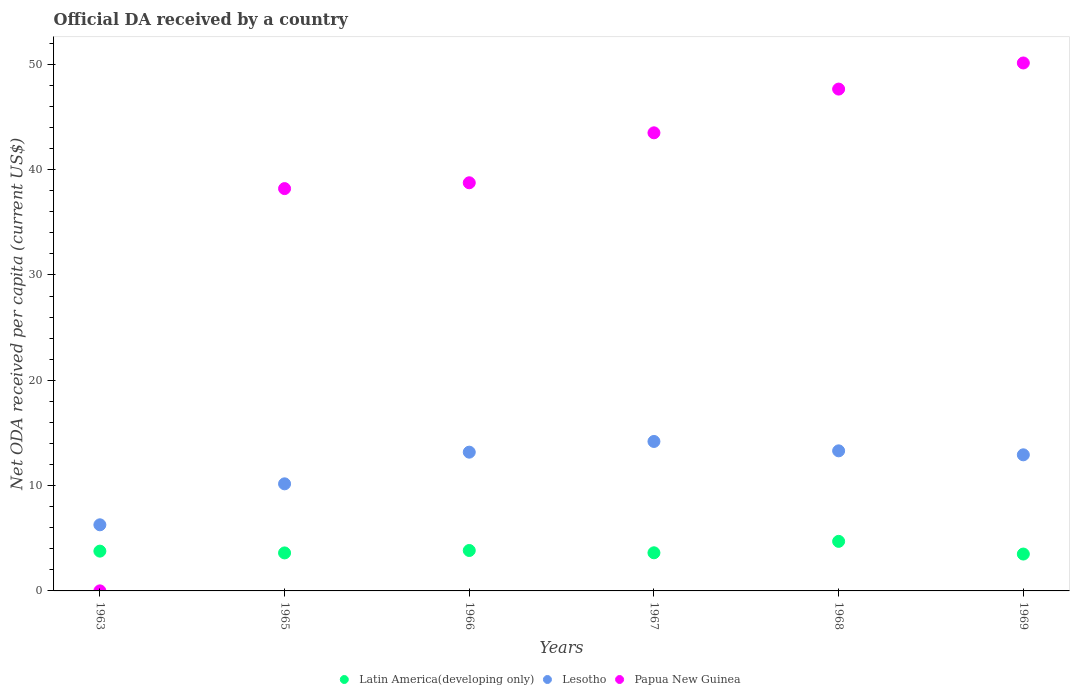How many different coloured dotlines are there?
Provide a succinct answer. 3. Is the number of dotlines equal to the number of legend labels?
Your answer should be compact. Yes. What is the ODA received in in Papua New Guinea in 1965?
Your response must be concise. 38.2. Across all years, what is the maximum ODA received in in Latin America(developing only)?
Your response must be concise. 4.71. Across all years, what is the minimum ODA received in in Latin America(developing only)?
Make the answer very short. 3.5. In which year was the ODA received in in Papua New Guinea maximum?
Your answer should be very brief. 1969. In which year was the ODA received in in Latin America(developing only) minimum?
Provide a succinct answer. 1969. What is the total ODA received in in Lesotho in the graph?
Make the answer very short. 70.04. What is the difference between the ODA received in in Papua New Guinea in 1966 and that in 1968?
Provide a succinct answer. -8.9. What is the difference between the ODA received in in Lesotho in 1969 and the ODA received in in Latin America(developing only) in 1968?
Your answer should be very brief. 8.22. What is the average ODA received in in Papua New Guinea per year?
Offer a terse response. 36.37. In the year 1968, what is the difference between the ODA received in in Lesotho and ODA received in in Latin America(developing only)?
Your response must be concise. 8.6. What is the ratio of the ODA received in in Latin America(developing only) in 1967 to that in 1968?
Offer a terse response. 0.77. Is the difference between the ODA received in in Lesotho in 1966 and 1968 greater than the difference between the ODA received in in Latin America(developing only) in 1966 and 1968?
Give a very brief answer. Yes. What is the difference between the highest and the second highest ODA received in in Papua New Guinea?
Keep it short and to the point. 2.48. What is the difference between the highest and the lowest ODA received in in Latin America(developing only)?
Give a very brief answer. 1.2. Is the sum of the ODA received in in Papua New Guinea in 1967 and 1969 greater than the maximum ODA received in in Latin America(developing only) across all years?
Keep it short and to the point. Yes. Is the ODA received in in Lesotho strictly greater than the ODA received in in Latin America(developing only) over the years?
Your answer should be very brief. Yes. How many dotlines are there?
Offer a terse response. 3. Are the values on the major ticks of Y-axis written in scientific E-notation?
Make the answer very short. No. How are the legend labels stacked?
Offer a very short reply. Horizontal. What is the title of the graph?
Offer a terse response. Official DA received by a country. Does "Middle East & North Africa (developing only)" appear as one of the legend labels in the graph?
Make the answer very short. No. What is the label or title of the X-axis?
Your answer should be compact. Years. What is the label or title of the Y-axis?
Provide a short and direct response. Net ODA received per capita (current US$). What is the Net ODA received per capita (current US$) in Latin America(developing only) in 1963?
Offer a very short reply. 3.78. What is the Net ODA received per capita (current US$) of Lesotho in 1963?
Ensure brevity in your answer.  6.28. What is the Net ODA received per capita (current US$) of Papua New Guinea in 1963?
Give a very brief answer. 0. What is the Net ODA received per capita (current US$) in Latin America(developing only) in 1965?
Your response must be concise. 3.61. What is the Net ODA received per capita (current US$) in Lesotho in 1965?
Provide a succinct answer. 10.17. What is the Net ODA received per capita (current US$) of Papua New Guinea in 1965?
Ensure brevity in your answer.  38.2. What is the Net ODA received per capita (current US$) in Latin America(developing only) in 1966?
Offer a terse response. 3.84. What is the Net ODA received per capita (current US$) of Lesotho in 1966?
Provide a short and direct response. 13.18. What is the Net ODA received per capita (current US$) in Papua New Guinea in 1966?
Offer a terse response. 38.76. What is the Net ODA received per capita (current US$) of Latin America(developing only) in 1967?
Your response must be concise. 3.62. What is the Net ODA received per capita (current US$) of Lesotho in 1967?
Provide a succinct answer. 14.19. What is the Net ODA received per capita (current US$) of Papua New Guinea in 1967?
Provide a short and direct response. 43.5. What is the Net ODA received per capita (current US$) of Latin America(developing only) in 1968?
Give a very brief answer. 4.71. What is the Net ODA received per capita (current US$) of Lesotho in 1968?
Give a very brief answer. 13.3. What is the Net ODA received per capita (current US$) of Papua New Guinea in 1968?
Ensure brevity in your answer.  47.65. What is the Net ODA received per capita (current US$) in Latin America(developing only) in 1969?
Keep it short and to the point. 3.5. What is the Net ODA received per capita (current US$) of Lesotho in 1969?
Provide a short and direct response. 12.92. What is the Net ODA received per capita (current US$) in Papua New Guinea in 1969?
Provide a succinct answer. 50.13. Across all years, what is the maximum Net ODA received per capita (current US$) of Latin America(developing only)?
Give a very brief answer. 4.71. Across all years, what is the maximum Net ODA received per capita (current US$) of Lesotho?
Provide a succinct answer. 14.19. Across all years, what is the maximum Net ODA received per capita (current US$) in Papua New Guinea?
Your answer should be compact. 50.13. Across all years, what is the minimum Net ODA received per capita (current US$) of Latin America(developing only)?
Make the answer very short. 3.5. Across all years, what is the minimum Net ODA received per capita (current US$) in Lesotho?
Your response must be concise. 6.28. Across all years, what is the minimum Net ODA received per capita (current US$) in Papua New Guinea?
Keep it short and to the point. 0. What is the total Net ODA received per capita (current US$) of Latin America(developing only) in the graph?
Offer a very short reply. 23.05. What is the total Net ODA received per capita (current US$) in Lesotho in the graph?
Give a very brief answer. 70.04. What is the total Net ODA received per capita (current US$) in Papua New Guinea in the graph?
Give a very brief answer. 218.25. What is the difference between the Net ODA received per capita (current US$) of Latin America(developing only) in 1963 and that in 1965?
Your answer should be compact. 0.17. What is the difference between the Net ODA received per capita (current US$) of Lesotho in 1963 and that in 1965?
Your response must be concise. -3.89. What is the difference between the Net ODA received per capita (current US$) of Papua New Guinea in 1963 and that in 1965?
Your answer should be very brief. -38.2. What is the difference between the Net ODA received per capita (current US$) of Latin America(developing only) in 1963 and that in 1966?
Your answer should be very brief. -0.06. What is the difference between the Net ODA received per capita (current US$) in Lesotho in 1963 and that in 1966?
Your answer should be compact. -6.9. What is the difference between the Net ODA received per capita (current US$) of Papua New Guinea in 1963 and that in 1966?
Your response must be concise. -38.75. What is the difference between the Net ODA received per capita (current US$) of Latin America(developing only) in 1963 and that in 1967?
Provide a succinct answer. 0.16. What is the difference between the Net ODA received per capita (current US$) in Lesotho in 1963 and that in 1967?
Provide a succinct answer. -7.91. What is the difference between the Net ODA received per capita (current US$) in Papua New Guinea in 1963 and that in 1967?
Give a very brief answer. -43.49. What is the difference between the Net ODA received per capita (current US$) of Latin America(developing only) in 1963 and that in 1968?
Provide a short and direct response. -0.93. What is the difference between the Net ODA received per capita (current US$) of Lesotho in 1963 and that in 1968?
Your response must be concise. -7.02. What is the difference between the Net ODA received per capita (current US$) in Papua New Guinea in 1963 and that in 1968?
Ensure brevity in your answer.  -47.65. What is the difference between the Net ODA received per capita (current US$) in Latin America(developing only) in 1963 and that in 1969?
Offer a terse response. 0.28. What is the difference between the Net ODA received per capita (current US$) in Lesotho in 1963 and that in 1969?
Make the answer very short. -6.65. What is the difference between the Net ODA received per capita (current US$) in Papua New Guinea in 1963 and that in 1969?
Offer a terse response. -50.13. What is the difference between the Net ODA received per capita (current US$) of Latin America(developing only) in 1965 and that in 1966?
Your response must be concise. -0.23. What is the difference between the Net ODA received per capita (current US$) of Lesotho in 1965 and that in 1966?
Your answer should be compact. -3.01. What is the difference between the Net ODA received per capita (current US$) in Papua New Guinea in 1965 and that in 1966?
Provide a short and direct response. -0.55. What is the difference between the Net ODA received per capita (current US$) in Latin America(developing only) in 1965 and that in 1967?
Provide a short and direct response. -0.01. What is the difference between the Net ODA received per capita (current US$) in Lesotho in 1965 and that in 1967?
Give a very brief answer. -4.02. What is the difference between the Net ODA received per capita (current US$) in Papua New Guinea in 1965 and that in 1967?
Offer a terse response. -5.3. What is the difference between the Net ODA received per capita (current US$) of Latin America(developing only) in 1965 and that in 1968?
Your answer should be very brief. -1.1. What is the difference between the Net ODA received per capita (current US$) of Lesotho in 1965 and that in 1968?
Offer a very short reply. -3.13. What is the difference between the Net ODA received per capita (current US$) of Papua New Guinea in 1965 and that in 1968?
Keep it short and to the point. -9.45. What is the difference between the Net ODA received per capita (current US$) of Latin America(developing only) in 1965 and that in 1969?
Offer a terse response. 0.11. What is the difference between the Net ODA received per capita (current US$) of Lesotho in 1965 and that in 1969?
Provide a succinct answer. -2.76. What is the difference between the Net ODA received per capita (current US$) in Papua New Guinea in 1965 and that in 1969?
Your answer should be very brief. -11.93. What is the difference between the Net ODA received per capita (current US$) of Latin America(developing only) in 1966 and that in 1967?
Your answer should be compact. 0.22. What is the difference between the Net ODA received per capita (current US$) of Lesotho in 1966 and that in 1967?
Keep it short and to the point. -1.02. What is the difference between the Net ODA received per capita (current US$) in Papua New Guinea in 1966 and that in 1967?
Keep it short and to the point. -4.74. What is the difference between the Net ODA received per capita (current US$) in Latin America(developing only) in 1966 and that in 1968?
Your answer should be very brief. -0.87. What is the difference between the Net ODA received per capita (current US$) in Lesotho in 1966 and that in 1968?
Provide a succinct answer. -0.13. What is the difference between the Net ODA received per capita (current US$) in Papua New Guinea in 1966 and that in 1968?
Offer a terse response. -8.9. What is the difference between the Net ODA received per capita (current US$) in Latin America(developing only) in 1966 and that in 1969?
Give a very brief answer. 0.34. What is the difference between the Net ODA received per capita (current US$) of Lesotho in 1966 and that in 1969?
Provide a short and direct response. 0.25. What is the difference between the Net ODA received per capita (current US$) in Papua New Guinea in 1966 and that in 1969?
Ensure brevity in your answer.  -11.38. What is the difference between the Net ODA received per capita (current US$) of Latin America(developing only) in 1967 and that in 1968?
Provide a short and direct response. -1.09. What is the difference between the Net ODA received per capita (current US$) in Lesotho in 1967 and that in 1968?
Ensure brevity in your answer.  0.89. What is the difference between the Net ODA received per capita (current US$) of Papua New Guinea in 1967 and that in 1968?
Your answer should be very brief. -4.15. What is the difference between the Net ODA received per capita (current US$) of Latin America(developing only) in 1967 and that in 1969?
Give a very brief answer. 0.12. What is the difference between the Net ODA received per capita (current US$) of Lesotho in 1967 and that in 1969?
Your answer should be very brief. 1.27. What is the difference between the Net ODA received per capita (current US$) of Papua New Guinea in 1967 and that in 1969?
Make the answer very short. -6.63. What is the difference between the Net ODA received per capita (current US$) of Latin America(developing only) in 1968 and that in 1969?
Your answer should be compact. 1.2. What is the difference between the Net ODA received per capita (current US$) in Lesotho in 1968 and that in 1969?
Your answer should be compact. 0.38. What is the difference between the Net ODA received per capita (current US$) in Papua New Guinea in 1968 and that in 1969?
Give a very brief answer. -2.48. What is the difference between the Net ODA received per capita (current US$) in Latin America(developing only) in 1963 and the Net ODA received per capita (current US$) in Lesotho in 1965?
Your answer should be compact. -6.39. What is the difference between the Net ODA received per capita (current US$) in Latin America(developing only) in 1963 and the Net ODA received per capita (current US$) in Papua New Guinea in 1965?
Offer a terse response. -34.42. What is the difference between the Net ODA received per capita (current US$) of Lesotho in 1963 and the Net ODA received per capita (current US$) of Papua New Guinea in 1965?
Keep it short and to the point. -31.92. What is the difference between the Net ODA received per capita (current US$) in Latin America(developing only) in 1963 and the Net ODA received per capita (current US$) in Lesotho in 1966?
Keep it short and to the point. -9.4. What is the difference between the Net ODA received per capita (current US$) of Latin America(developing only) in 1963 and the Net ODA received per capita (current US$) of Papua New Guinea in 1966?
Your answer should be very brief. -34.98. What is the difference between the Net ODA received per capita (current US$) of Lesotho in 1963 and the Net ODA received per capita (current US$) of Papua New Guinea in 1966?
Make the answer very short. -32.48. What is the difference between the Net ODA received per capita (current US$) in Latin America(developing only) in 1963 and the Net ODA received per capita (current US$) in Lesotho in 1967?
Keep it short and to the point. -10.41. What is the difference between the Net ODA received per capita (current US$) in Latin America(developing only) in 1963 and the Net ODA received per capita (current US$) in Papua New Guinea in 1967?
Keep it short and to the point. -39.72. What is the difference between the Net ODA received per capita (current US$) in Lesotho in 1963 and the Net ODA received per capita (current US$) in Papua New Guinea in 1967?
Keep it short and to the point. -37.22. What is the difference between the Net ODA received per capita (current US$) in Latin America(developing only) in 1963 and the Net ODA received per capita (current US$) in Lesotho in 1968?
Your answer should be very brief. -9.52. What is the difference between the Net ODA received per capita (current US$) in Latin America(developing only) in 1963 and the Net ODA received per capita (current US$) in Papua New Guinea in 1968?
Ensure brevity in your answer.  -43.87. What is the difference between the Net ODA received per capita (current US$) of Lesotho in 1963 and the Net ODA received per capita (current US$) of Papua New Guinea in 1968?
Make the answer very short. -41.37. What is the difference between the Net ODA received per capita (current US$) in Latin America(developing only) in 1963 and the Net ODA received per capita (current US$) in Lesotho in 1969?
Ensure brevity in your answer.  -9.15. What is the difference between the Net ODA received per capita (current US$) of Latin America(developing only) in 1963 and the Net ODA received per capita (current US$) of Papua New Guinea in 1969?
Provide a short and direct response. -46.35. What is the difference between the Net ODA received per capita (current US$) of Lesotho in 1963 and the Net ODA received per capita (current US$) of Papua New Guinea in 1969?
Provide a succinct answer. -43.85. What is the difference between the Net ODA received per capita (current US$) of Latin America(developing only) in 1965 and the Net ODA received per capita (current US$) of Lesotho in 1966?
Provide a short and direct response. -9.57. What is the difference between the Net ODA received per capita (current US$) in Latin America(developing only) in 1965 and the Net ODA received per capita (current US$) in Papua New Guinea in 1966?
Offer a terse response. -35.15. What is the difference between the Net ODA received per capita (current US$) in Lesotho in 1965 and the Net ODA received per capita (current US$) in Papua New Guinea in 1966?
Your response must be concise. -28.59. What is the difference between the Net ODA received per capita (current US$) in Latin America(developing only) in 1965 and the Net ODA received per capita (current US$) in Lesotho in 1967?
Offer a terse response. -10.58. What is the difference between the Net ODA received per capita (current US$) in Latin America(developing only) in 1965 and the Net ODA received per capita (current US$) in Papua New Guinea in 1967?
Provide a succinct answer. -39.89. What is the difference between the Net ODA received per capita (current US$) in Lesotho in 1965 and the Net ODA received per capita (current US$) in Papua New Guinea in 1967?
Make the answer very short. -33.33. What is the difference between the Net ODA received per capita (current US$) in Latin America(developing only) in 1965 and the Net ODA received per capita (current US$) in Lesotho in 1968?
Offer a terse response. -9.69. What is the difference between the Net ODA received per capita (current US$) in Latin America(developing only) in 1965 and the Net ODA received per capita (current US$) in Papua New Guinea in 1968?
Keep it short and to the point. -44.04. What is the difference between the Net ODA received per capita (current US$) in Lesotho in 1965 and the Net ODA received per capita (current US$) in Papua New Guinea in 1968?
Provide a succinct answer. -37.48. What is the difference between the Net ODA received per capita (current US$) of Latin America(developing only) in 1965 and the Net ODA received per capita (current US$) of Lesotho in 1969?
Ensure brevity in your answer.  -9.32. What is the difference between the Net ODA received per capita (current US$) in Latin America(developing only) in 1965 and the Net ODA received per capita (current US$) in Papua New Guinea in 1969?
Your answer should be very brief. -46.52. What is the difference between the Net ODA received per capita (current US$) in Lesotho in 1965 and the Net ODA received per capita (current US$) in Papua New Guinea in 1969?
Provide a succinct answer. -39.96. What is the difference between the Net ODA received per capita (current US$) in Latin America(developing only) in 1966 and the Net ODA received per capita (current US$) in Lesotho in 1967?
Offer a very short reply. -10.35. What is the difference between the Net ODA received per capita (current US$) in Latin America(developing only) in 1966 and the Net ODA received per capita (current US$) in Papua New Guinea in 1967?
Your answer should be very brief. -39.66. What is the difference between the Net ODA received per capita (current US$) in Lesotho in 1966 and the Net ODA received per capita (current US$) in Papua New Guinea in 1967?
Your answer should be compact. -30.32. What is the difference between the Net ODA received per capita (current US$) in Latin America(developing only) in 1966 and the Net ODA received per capita (current US$) in Lesotho in 1968?
Your answer should be very brief. -9.46. What is the difference between the Net ODA received per capita (current US$) in Latin America(developing only) in 1966 and the Net ODA received per capita (current US$) in Papua New Guinea in 1968?
Provide a short and direct response. -43.81. What is the difference between the Net ODA received per capita (current US$) in Lesotho in 1966 and the Net ODA received per capita (current US$) in Papua New Guinea in 1968?
Offer a very short reply. -34.48. What is the difference between the Net ODA received per capita (current US$) of Latin America(developing only) in 1966 and the Net ODA received per capita (current US$) of Lesotho in 1969?
Make the answer very short. -9.08. What is the difference between the Net ODA received per capita (current US$) of Latin America(developing only) in 1966 and the Net ODA received per capita (current US$) of Papua New Guinea in 1969?
Offer a terse response. -46.29. What is the difference between the Net ODA received per capita (current US$) in Lesotho in 1966 and the Net ODA received per capita (current US$) in Papua New Guinea in 1969?
Offer a very short reply. -36.96. What is the difference between the Net ODA received per capita (current US$) of Latin America(developing only) in 1967 and the Net ODA received per capita (current US$) of Lesotho in 1968?
Ensure brevity in your answer.  -9.68. What is the difference between the Net ODA received per capita (current US$) in Latin America(developing only) in 1967 and the Net ODA received per capita (current US$) in Papua New Guinea in 1968?
Make the answer very short. -44.03. What is the difference between the Net ODA received per capita (current US$) of Lesotho in 1967 and the Net ODA received per capita (current US$) of Papua New Guinea in 1968?
Make the answer very short. -33.46. What is the difference between the Net ODA received per capita (current US$) in Latin America(developing only) in 1967 and the Net ODA received per capita (current US$) in Lesotho in 1969?
Offer a very short reply. -9.3. What is the difference between the Net ODA received per capita (current US$) of Latin America(developing only) in 1967 and the Net ODA received per capita (current US$) of Papua New Guinea in 1969?
Keep it short and to the point. -46.51. What is the difference between the Net ODA received per capita (current US$) in Lesotho in 1967 and the Net ODA received per capita (current US$) in Papua New Guinea in 1969?
Keep it short and to the point. -35.94. What is the difference between the Net ODA received per capita (current US$) of Latin America(developing only) in 1968 and the Net ODA received per capita (current US$) of Lesotho in 1969?
Provide a succinct answer. -8.22. What is the difference between the Net ODA received per capita (current US$) of Latin America(developing only) in 1968 and the Net ODA received per capita (current US$) of Papua New Guinea in 1969?
Ensure brevity in your answer.  -45.43. What is the difference between the Net ODA received per capita (current US$) of Lesotho in 1968 and the Net ODA received per capita (current US$) of Papua New Guinea in 1969?
Your answer should be compact. -36.83. What is the average Net ODA received per capita (current US$) in Latin America(developing only) per year?
Provide a succinct answer. 3.84. What is the average Net ODA received per capita (current US$) of Lesotho per year?
Provide a short and direct response. 11.67. What is the average Net ODA received per capita (current US$) of Papua New Guinea per year?
Give a very brief answer. 36.37. In the year 1963, what is the difference between the Net ODA received per capita (current US$) in Latin America(developing only) and Net ODA received per capita (current US$) in Lesotho?
Ensure brevity in your answer.  -2.5. In the year 1963, what is the difference between the Net ODA received per capita (current US$) of Latin America(developing only) and Net ODA received per capita (current US$) of Papua New Guinea?
Your answer should be compact. 3.77. In the year 1963, what is the difference between the Net ODA received per capita (current US$) in Lesotho and Net ODA received per capita (current US$) in Papua New Guinea?
Your response must be concise. 6.27. In the year 1965, what is the difference between the Net ODA received per capita (current US$) of Latin America(developing only) and Net ODA received per capita (current US$) of Lesotho?
Your answer should be compact. -6.56. In the year 1965, what is the difference between the Net ODA received per capita (current US$) of Latin America(developing only) and Net ODA received per capita (current US$) of Papua New Guinea?
Offer a very short reply. -34.59. In the year 1965, what is the difference between the Net ODA received per capita (current US$) in Lesotho and Net ODA received per capita (current US$) in Papua New Guinea?
Offer a very short reply. -28.03. In the year 1966, what is the difference between the Net ODA received per capita (current US$) in Latin America(developing only) and Net ODA received per capita (current US$) in Lesotho?
Offer a very short reply. -9.34. In the year 1966, what is the difference between the Net ODA received per capita (current US$) in Latin America(developing only) and Net ODA received per capita (current US$) in Papua New Guinea?
Provide a short and direct response. -34.92. In the year 1966, what is the difference between the Net ODA received per capita (current US$) in Lesotho and Net ODA received per capita (current US$) in Papua New Guinea?
Give a very brief answer. -25.58. In the year 1967, what is the difference between the Net ODA received per capita (current US$) in Latin America(developing only) and Net ODA received per capita (current US$) in Lesotho?
Your answer should be very brief. -10.57. In the year 1967, what is the difference between the Net ODA received per capita (current US$) of Latin America(developing only) and Net ODA received per capita (current US$) of Papua New Guinea?
Your response must be concise. -39.88. In the year 1967, what is the difference between the Net ODA received per capita (current US$) of Lesotho and Net ODA received per capita (current US$) of Papua New Guinea?
Make the answer very short. -29.31. In the year 1968, what is the difference between the Net ODA received per capita (current US$) in Latin America(developing only) and Net ODA received per capita (current US$) in Lesotho?
Your answer should be very brief. -8.6. In the year 1968, what is the difference between the Net ODA received per capita (current US$) of Latin America(developing only) and Net ODA received per capita (current US$) of Papua New Guinea?
Give a very brief answer. -42.95. In the year 1968, what is the difference between the Net ODA received per capita (current US$) of Lesotho and Net ODA received per capita (current US$) of Papua New Guinea?
Ensure brevity in your answer.  -34.35. In the year 1969, what is the difference between the Net ODA received per capita (current US$) in Latin America(developing only) and Net ODA received per capita (current US$) in Lesotho?
Provide a short and direct response. -9.42. In the year 1969, what is the difference between the Net ODA received per capita (current US$) of Latin America(developing only) and Net ODA received per capita (current US$) of Papua New Guinea?
Ensure brevity in your answer.  -46.63. In the year 1969, what is the difference between the Net ODA received per capita (current US$) in Lesotho and Net ODA received per capita (current US$) in Papua New Guinea?
Provide a succinct answer. -37.21. What is the ratio of the Net ODA received per capita (current US$) in Latin America(developing only) in 1963 to that in 1965?
Your answer should be very brief. 1.05. What is the ratio of the Net ODA received per capita (current US$) in Lesotho in 1963 to that in 1965?
Provide a short and direct response. 0.62. What is the ratio of the Net ODA received per capita (current US$) of Latin America(developing only) in 1963 to that in 1966?
Ensure brevity in your answer.  0.98. What is the ratio of the Net ODA received per capita (current US$) of Lesotho in 1963 to that in 1966?
Your answer should be compact. 0.48. What is the ratio of the Net ODA received per capita (current US$) in Papua New Guinea in 1963 to that in 1966?
Keep it short and to the point. 0. What is the ratio of the Net ODA received per capita (current US$) of Latin America(developing only) in 1963 to that in 1967?
Provide a succinct answer. 1.04. What is the ratio of the Net ODA received per capita (current US$) of Lesotho in 1963 to that in 1967?
Your answer should be compact. 0.44. What is the ratio of the Net ODA received per capita (current US$) of Papua New Guinea in 1963 to that in 1967?
Offer a terse response. 0. What is the ratio of the Net ODA received per capita (current US$) of Latin America(developing only) in 1963 to that in 1968?
Provide a short and direct response. 0.8. What is the ratio of the Net ODA received per capita (current US$) of Lesotho in 1963 to that in 1968?
Keep it short and to the point. 0.47. What is the ratio of the Net ODA received per capita (current US$) of Papua New Guinea in 1963 to that in 1968?
Ensure brevity in your answer.  0. What is the ratio of the Net ODA received per capita (current US$) of Latin America(developing only) in 1963 to that in 1969?
Provide a succinct answer. 1.08. What is the ratio of the Net ODA received per capita (current US$) of Lesotho in 1963 to that in 1969?
Give a very brief answer. 0.49. What is the ratio of the Net ODA received per capita (current US$) in Latin America(developing only) in 1965 to that in 1966?
Give a very brief answer. 0.94. What is the ratio of the Net ODA received per capita (current US$) of Lesotho in 1965 to that in 1966?
Ensure brevity in your answer.  0.77. What is the ratio of the Net ODA received per capita (current US$) of Papua New Guinea in 1965 to that in 1966?
Offer a very short reply. 0.99. What is the ratio of the Net ODA received per capita (current US$) of Latin America(developing only) in 1965 to that in 1967?
Offer a terse response. 1. What is the ratio of the Net ODA received per capita (current US$) of Lesotho in 1965 to that in 1967?
Keep it short and to the point. 0.72. What is the ratio of the Net ODA received per capita (current US$) of Papua New Guinea in 1965 to that in 1967?
Your answer should be compact. 0.88. What is the ratio of the Net ODA received per capita (current US$) of Latin America(developing only) in 1965 to that in 1968?
Provide a short and direct response. 0.77. What is the ratio of the Net ODA received per capita (current US$) of Lesotho in 1965 to that in 1968?
Your answer should be compact. 0.76. What is the ratio of the Net ODA received per capita (current US$) in Papua New Guinea in 1965 to that in 1968?
Keep it short and to the point. 0.8. What is the ratio of the Net ODA received per capita (current US$) of Latin America(developing only) in 1965 to that in 1969?
Make the answer very short. 1.03. What is the ratio of the Net ODA received per capita (current US$) of Lesotho in 1965 to that in 1969?
Your answer should be very brief. 0.79. What is the ratio of the Net ODA received per capita (current US$) of Papua New Guinea in 1965 to that in 1969?
Offer a terse response. 0.76. What is the ratio of the Net ODA received per capita (current US$) in Latin America(developing only) in 1966 to that in 1967?
Provide a succinct answer. 1.06. What is the ratio of the Net ODA received per capita (current US$) of Lesotho in 1966 to that in 1967?
Provide a succinct answer. 0.93. What is the ratio of the Net ODA received per capita (current US$) of Papua New Guinea in 1966 to that in 1967?
Your answer should be very brief. 0.89. What is the ratio of the Net ODA received per capita (current US$) of Latin America(developing only) in 1966 to that in 1968?
Make the answer very short. 0.82. What is the ratio of the Net ODA received per capita (current US$) of Lesotho in 1966 to that in 1968?
Your answer should be very brief. 0.99. What is the ratio of the Net ODA received per capita (current US$) of Papua New Guinea in 1966 to that in 1968?
Offer a terse response. 0.81. What is the ratio of the Net ODA received per capita (current US$) of Latin America(developing only) in 1966 to that in 1969?
Make the answer very short. 1.1. What is the ratio of the Net ODA received per capita (current US$) in Lesotho in 1966 to that in 1969?
Make the answer very short. 1.02. What is the ratio of the Net ODA received per capita (current US$) in Papua New Guinea in 1966 to that in 1969?
Your response must be concise. 0.77. What is the ratio of the Net ODA received per capita (current US$) in Latin America(developing only) in 1967 to that in 1968?
Your answer should be compact. 0.77. What is the ratio of the Net ODA received per capita (current US$) of Lesotho in 1967 to that in 1968?
Your response must be concise. 1.07. What is the ratio of the Net ODA received per capita (current US$) in Papua New Guinea in 1967 to that in 1968?
Provide a short and direct response. 0.91. What is the ratio of the Net ODA received per capita (current US$) of Latin America(developing only) in 1967 to that in 1969?
Your answer should be compact. 1.03. What is the ratio of the Net ODA received per capita (current US$) of Lesotho in 1967 to that in 1969?
Your response must be concise. 1.1. What is the ratio of the Net ODA received per capita (current US$) of Papua New Guinea in 1967 to that in 1969?
Provide a succinct answer. 0.87. What is the ratio of the Net ODA received per capita (current US$) of Latin America(developing only) in 1968 to that in 1969?
Make the answer very short. 1.34. What is the ratio of the Net ODA received per capita (current US$) of Lesotho in 1968 to that in 1969?
Your answer should be very brief. 1.03. What is the ratio of the Net ODA received per capita (current US$) in Papua New Guinea in 1968 to that in 1969?
Keep it short and to the point. 0.95. What is the difference between the highest and the second highest Net ODA received per capita (current US$) of Latin America(developing only)?
Ensure brevity in your answer.  0.87. What is the difference between the highest and the second highest Net ODA received per capita (current US$) of Lesotho?
Your answer should be very brief. 0.89. What is the difference between the highest and the second highest Net ODA received per capita (current US$) of Papua New Guinea?
Offer a terse response. 2.48. What is the difference between the highest and the lowest Net ODA received per capita (current US$) in Latin America(developing only)?
Provide a succinct answer. 1.2. What is the difference between the highest and the lowest Net ODA received per capita (current US$) in Lesotho?
Provide a succinct answer. 7.91. What is the difference between the highest and the lowest Net ODA received per capita (current US$) in Papua New Guinea?
Your answer should be very brief. 50.13. 